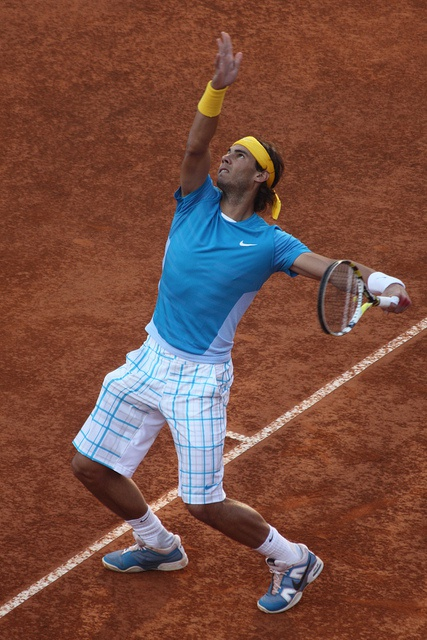Describe the objects in this image and their specific colors. I can see people in maroon, teal, lavender, and darkgray tones and tennis racket in maroon, gray, brown, and black tones in this image. 